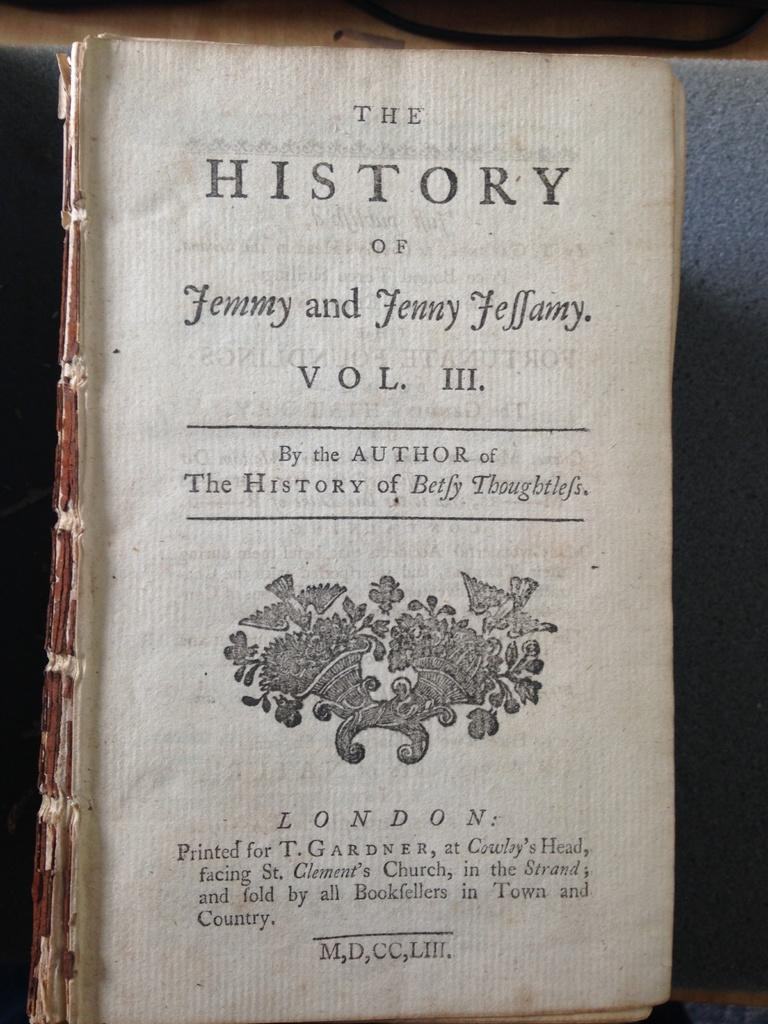<image>
Describe the image concisely. Vol III of the History of Jemmy and Jenny Jeffamy. 